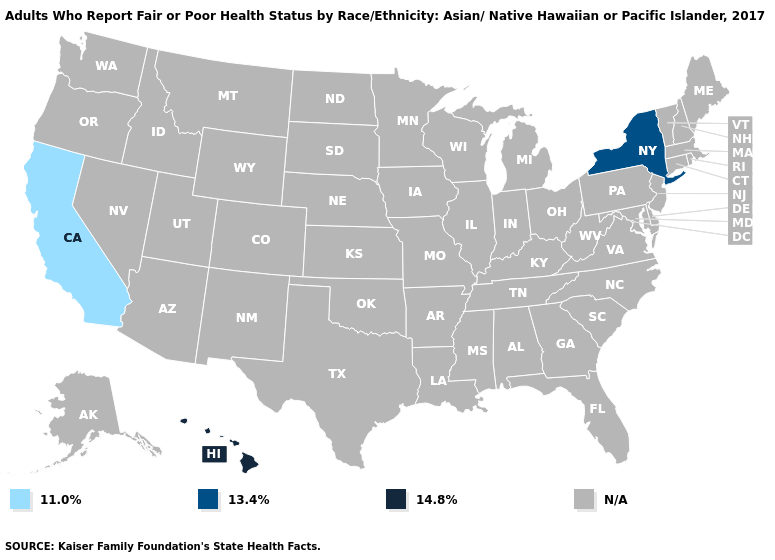What is the value of California?
Short answer required. 11.0%. Name the states that have a value in the range 14.8%?
Short answer required. Hawaii. What is the value of Arkansas?
Write a very short answer. N/A. Is the legend a continuous bar?
Write a very short answer. No. Does the first symbol in the legend represent the smallest category?
Concise answer only. Yes. Name the states that have a value in the range 11.0%?
Be succinct. California. What is the value of Utah?
Quick response, please. N/A. Name the states that have a value in the range 11.0%?
Quick response, please. California. What is the value of California?
Short answer required. 11.0%. What is the value of South Dakota?
Be succinct. N/A. 